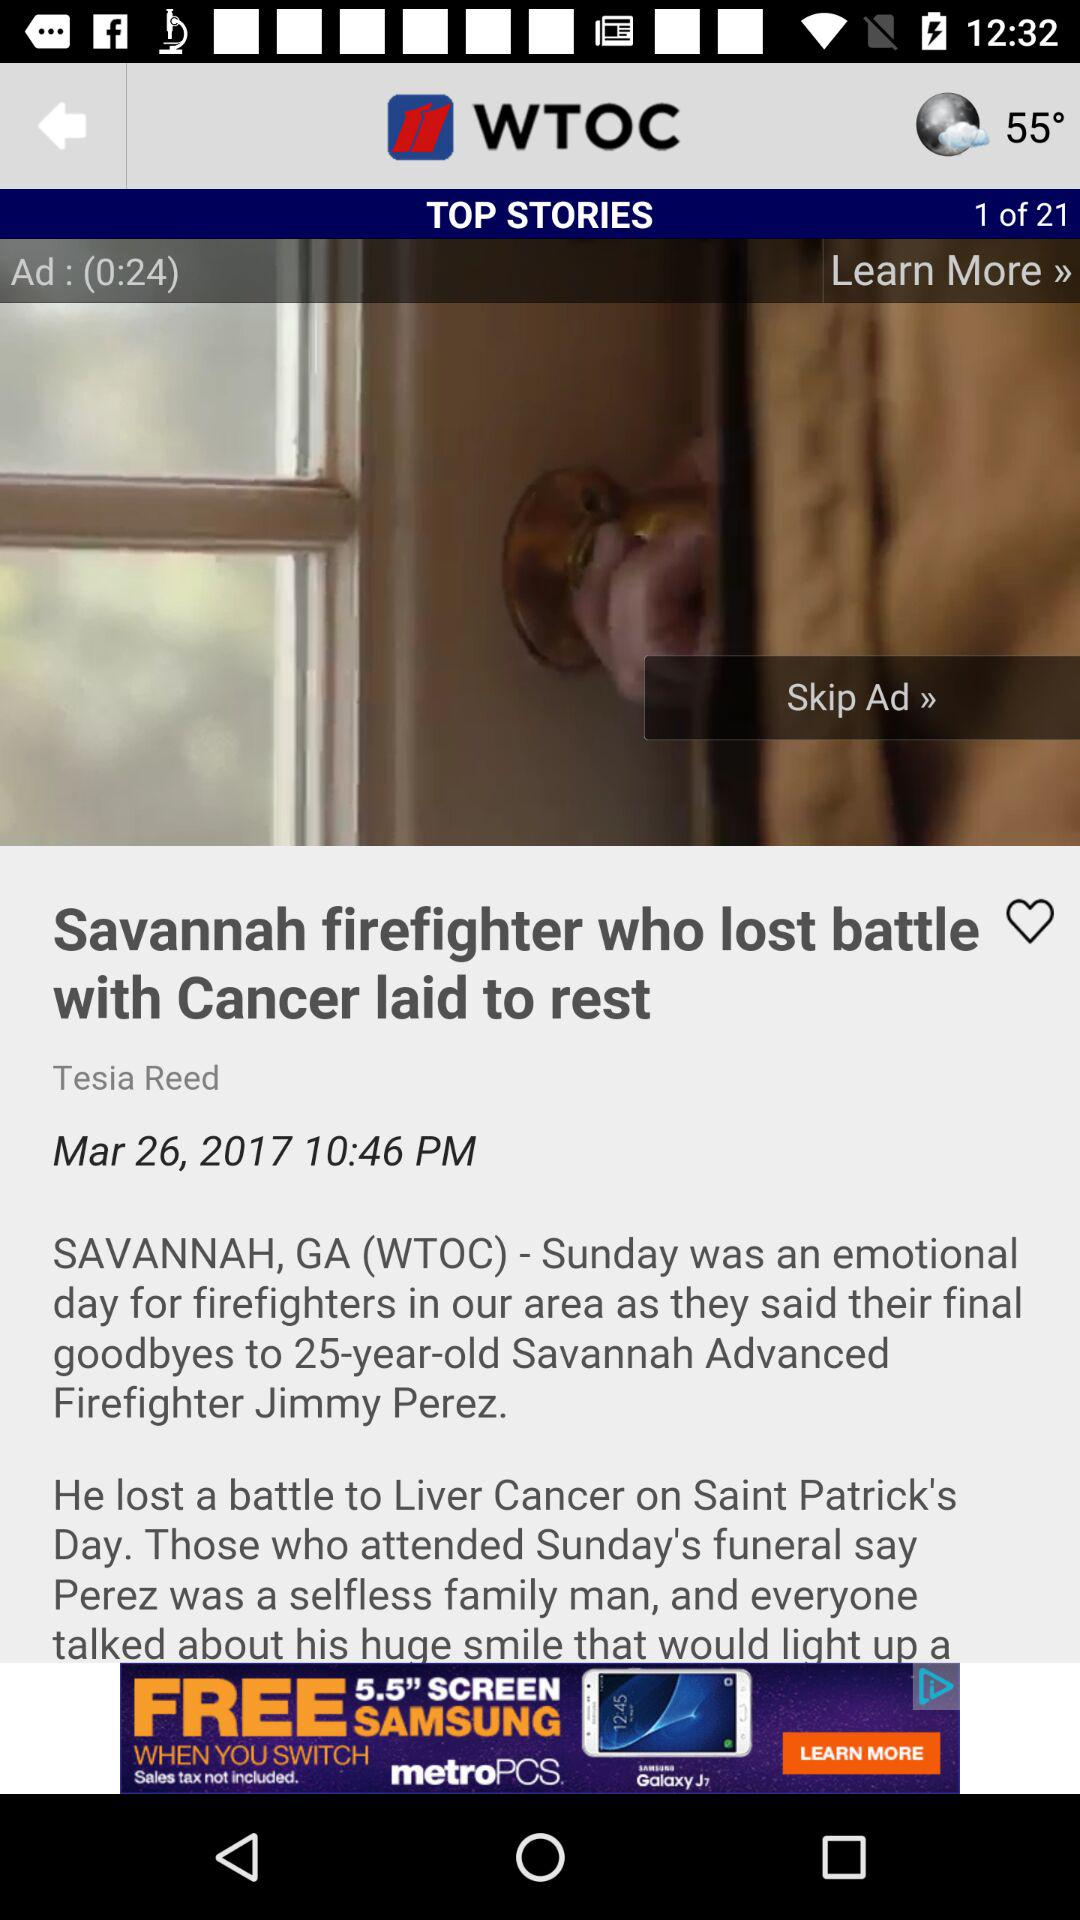What is the total number of stories? The total number of stories is 21. 